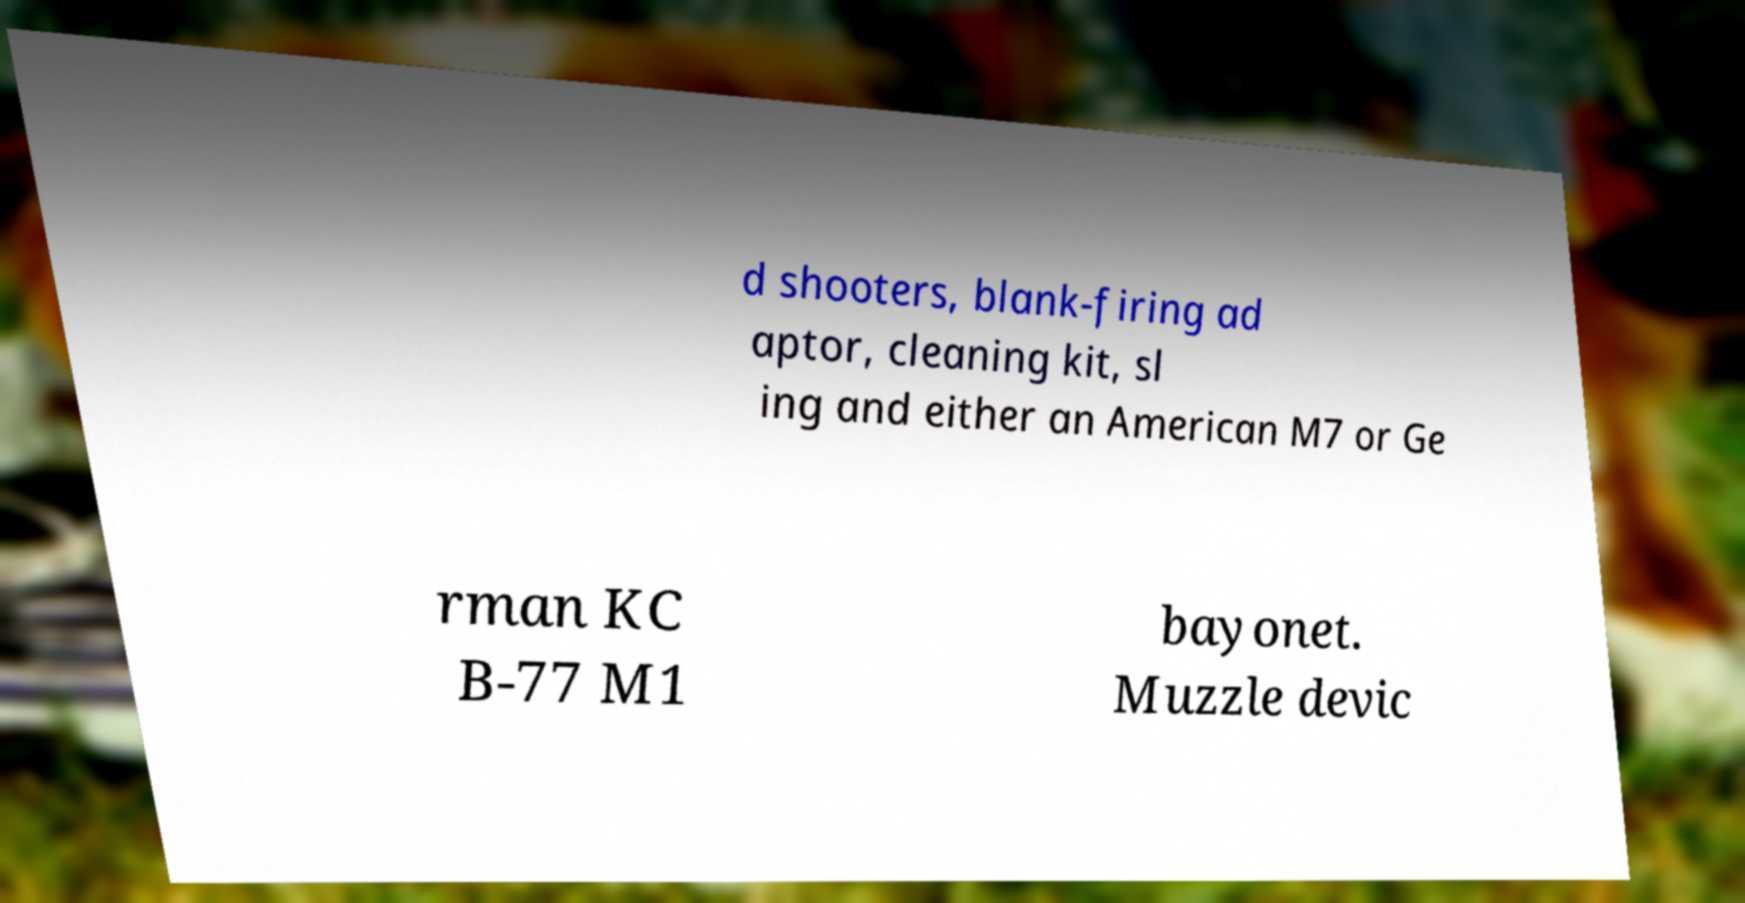Could you extract and type out the text from this image? d shooters, blank-firing ad aptor, cleaning kit, sl ing and either an American M7 or Ge rman KC B-77 M1 bayonet. Muzzle devic 